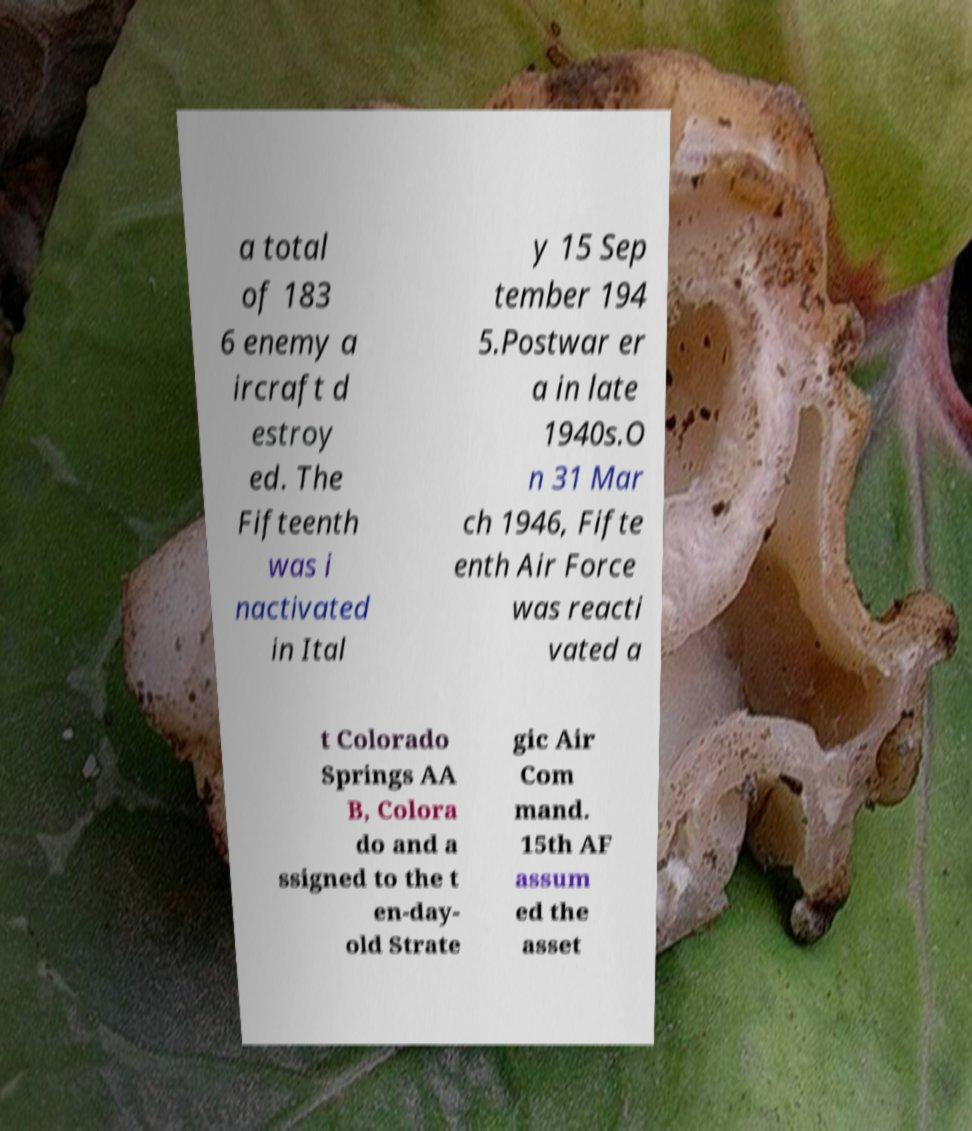Could you assist in decoding the text presented in this image and type it out clearly? a total of 183 6 enemy a ircraft d estroy ed. The Fifteenth was i nactivated in Ital y 15 Sep tember 194 5.Postwar er a in late 1940s.O n 31 Mar ch 1946, Fifte enth Air Force was reacti vated a t Colorado Springs AA B, Colora do and a ssigned to the t en-day- old Strate gic Air Com mand. 15th AF assum ed the asset 